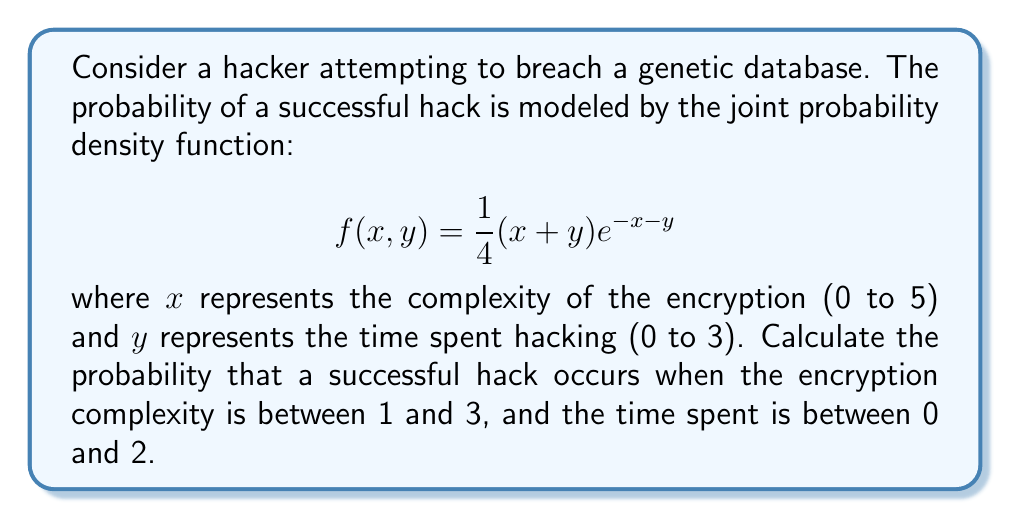Solve this math problem. To solve this problem, we need to evaluate the double integral of the given probability density function over the specified region. The integral will be:

$$P(\text{successful hack}) = \int_{0}^{2}\int_{1}^{3} \frac{1}{4}(x+y)e^{-x-y} \, dx \, dy$$

Let's evaluate this integral step by step:

1) First, let's integrate with respect to x:

   $$\int_{0}^{2}\int_{1}^{3} \frac{1}{4}(x+y)e^{-x-y} \, dx \, dy = \int_{0}^{2} \left[ -\frac{1}{4}(x+y+1)e^{-x-y} \right]_{1}^{3} \, dy$$

2) Evaluating the inner integral:

   $$= \int_{0}^{2} \left[ -\frac{1}{4}(3+y+1)e^{-3-y} + \frac{1}{4}(1+y+1)e^{-1-y} \right] \, dy$$

3) Simplify:

   $$= \int_{0}^{2} \left[ -\frac{1}{4}(4+y)e^{-3-y} + \frac{1}{4}(2+y)e^{-1-y} \right] \, dy$$

4) Now, let's integrate with respect to y:

   $$= \left[ \frac{1}{4}(5+y)e^{-3-y} - \frac{1}{4}(3+y)e^{-1-y} \right]_{0}^{2}$$

5) Evaluate at the limits:

   $$= \left[ \frac{1}{4}(7)e^{-5} - \frac{1}{4}(5)e^{-3} \right] - \left[ \frac{1}{4}(5)e^{-3} - \frac{1}{4}(3)e^{-1} \right]$$

6) Simplify:

   $$= \frac{7e^{-5}}{4} - \frac{5e^{-3}}{4} - \frac{5e^{-3}}{4} + \frac{3e^{-1}}{4}$$

   $$= \frac{7e^{-5} - 10e^{-3} + 3e^{-1}}{4}$$

This is the exact solution. For a numerical approximation:

$$\approx 0.1839$$
Answer: The probability of a successful hack under the given conditions is $\frac{7e^{-5} - 10e^{-3} + 3e^{-1}}{4}$, or approximately 0.1839. 